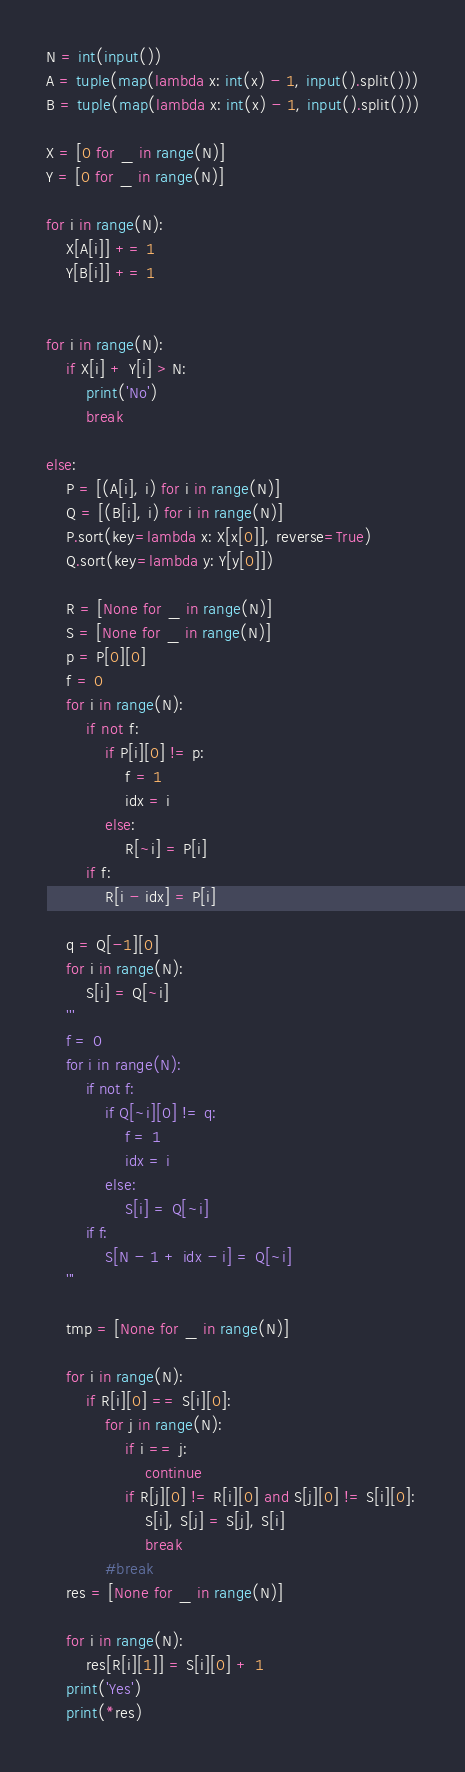<code> <loc_0><loc_0><loc_500><loc_500><_Python_>N = int(input())
A = tuple(map(lambda x: int(x) - 1, input().split()))
B = tuple(map(lambda x: int(x) - 1, input().split()))

X = [0 for _ in range(N)]
Y = [0 for _ in range(N)]

for i in range(N):
    X[A[i]] += 1
    Y[B[i]] += 1


for i in range(N):
    if X[i] + Y[i] > N:
        print('No')
        break

else:
    P = [(A[i], i) for i in range(N)]
    Q = [(B[i], i) for i in range(N)]
    P.sort(key=lambda x: X[x[0]], reverse=True)
    Q.sort(key=lambda y: Y[y[0]])

    R = [None for _ in range(N)]
    S = [None for _ in range(N)]
    p = P[0][0]
    f = 0
    for i in range(N):
        if not f:
            if P[i][0] != p:
                f = 1
                idx = i
            else:
                R[~i] = P[i]
        if f:
            R[i - idx] = P[i]

    q = Q[-1][0]
    for i in range(N):
        S[i] = Q[~i]
    '''
    f = 0
    for i in range(N):
        if not f:
            if Q[~i][0] != q:
                f = 1
                idx = i
            else:
                S[i] = Q[~i]
        if f:
            S[N - 1 + idx - i] = Q[~i]
    '''

    tmp = [None for _ in range(N)]

    for i in range(N):
        if R[i][0] == S[i][0]:
            for j in range(N):
                if i == j:
                    continue
                if R[j][0] != R[i][0] and S[j][0] != S[i][0]:
                    S[i], S[j] = S[j], S[i]
                    break
            #break
    res = [None for _ in range(N)]

    for i in range(N):
        res[R[i][1]] = S[i][0] + 1
    print('Yes')
    print(*res)</code> 